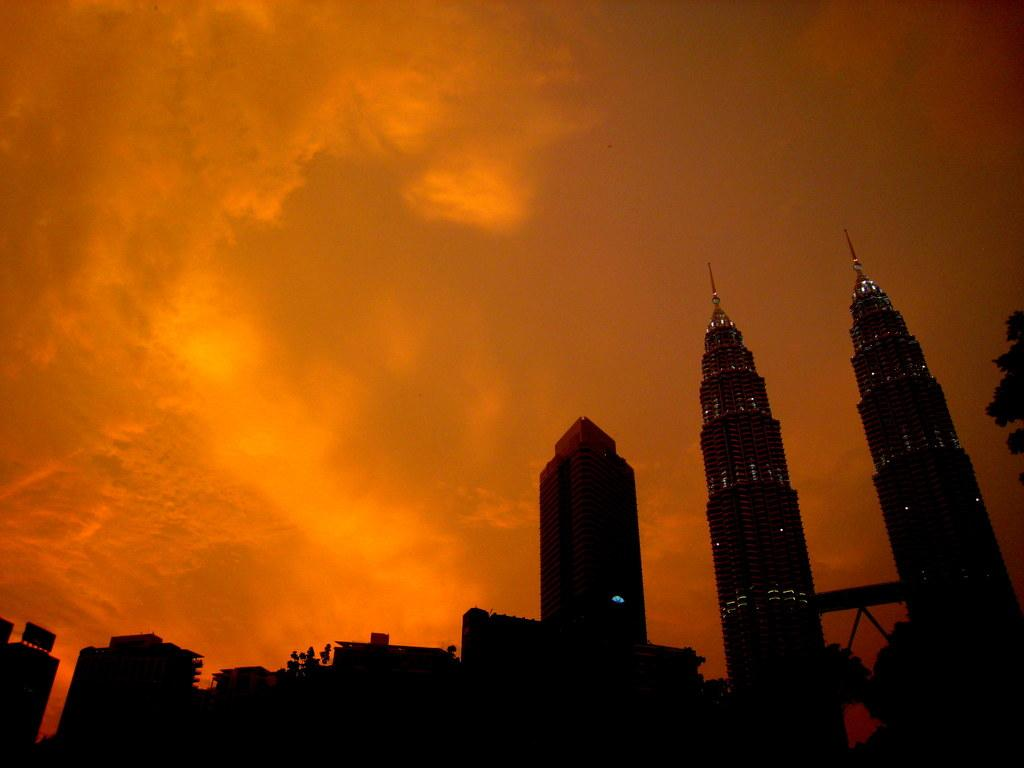What types of structures are present in the image? There are buildings in the image. What other natural elements can be seen in the image? There are trees in the image. What part of the natural environment is visible in the image? The sky is visible in the image. Where is the giraffe standing in the image? There is no giraffe present in the image. What type of lettuce can be seen growing in the image? There is no lettuce visible in the image. 